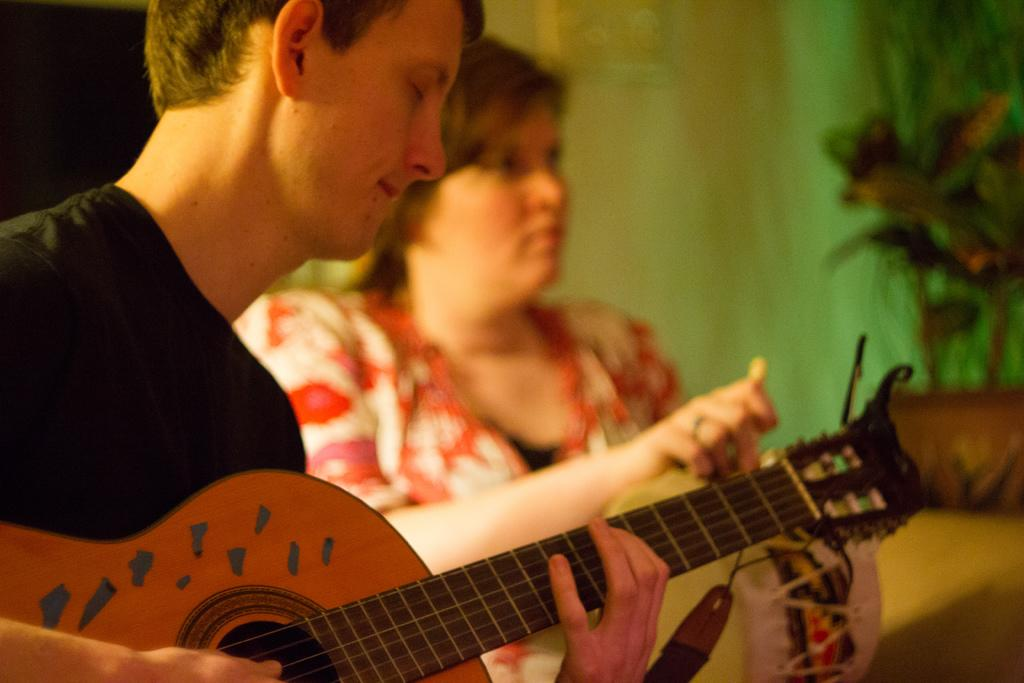How many people are in the image? There are two persons in the image. What is one of the persons doing in the image? One of the persons is playing a guitar. Can you describe the activity of the other person in the image? The other person's activity is not mentioned in the provided facts, so we cannot definitively describe it. What type of flower is being used as a pick for the guitar in the image? There is no flower present in the image, and the guitar is not being played with a pick. 